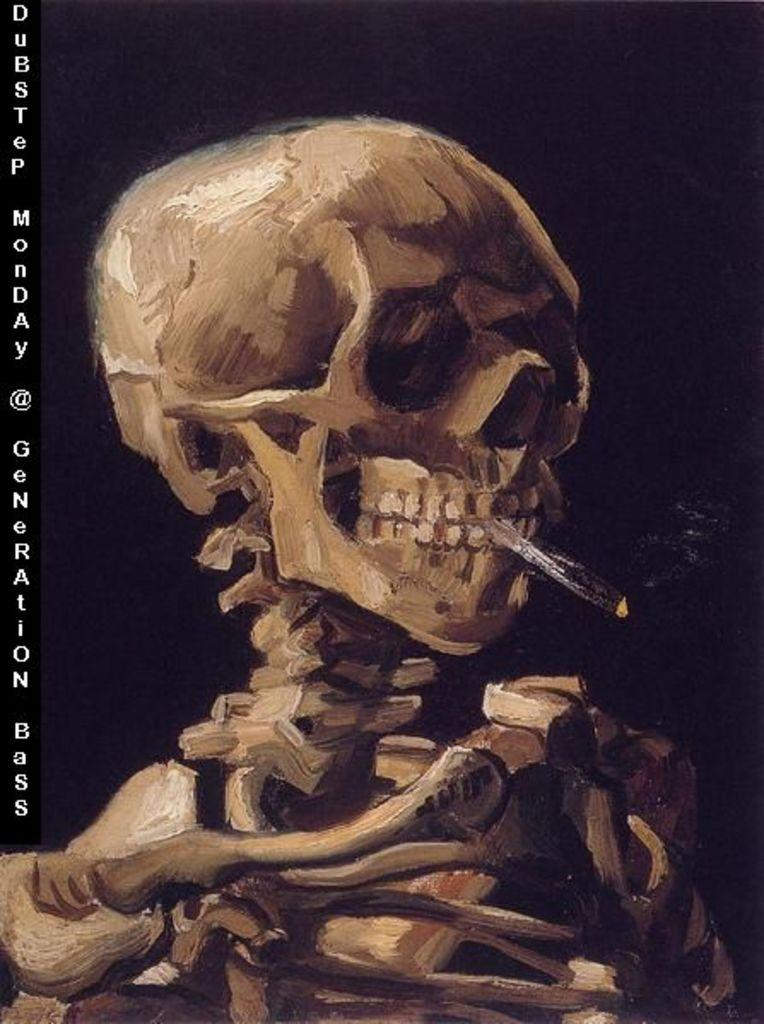What is the main subject of the image? There is a depiction of a skeleton in the image. Can you describe any additional features of the image? There is a watermark on the left side of the image. What is the color of the background in the image? The background of the image is dark. What type of sweater is the skeleton wearing in the image? There is no sweater present in the image, as the subject is a skeleton and does not have clothing. 